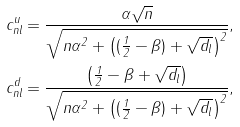Convert formula to latex. <formula><loc_0><loc_0><loc_500><loc_500>c _ { n l } ^ { u } = \frac { \alpha \sqrt { n } } { \sqrt { n \alpha ^ { 2 } + \left ( ( \frac { 1 } { 2 } - \beta ) + \sqrt { d _ { l } } \right ) ^ { 2 } } } , \\ c _ { n l } ^ { d } = \frac { \left ( \frac { 1 } { 2 } - \beta + \sqrt { d _ { l } } \right ) } { \sqrt { n \alpha ^ { 2 } + \left ( ( \frac { 1 } { 2 } - \beta ) + \sqrt { d _ { l } } \right ) ^ { 2 } } } ,</formula> 